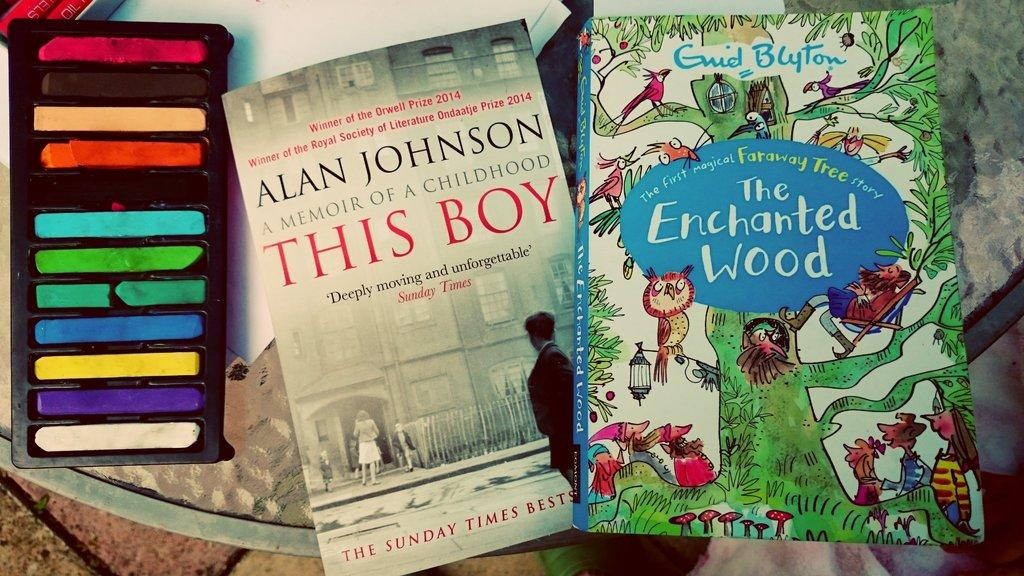Provide a one-sentence caption for the provided image. Two books sit on a glass table, one of which is The Enchanted Wood. 